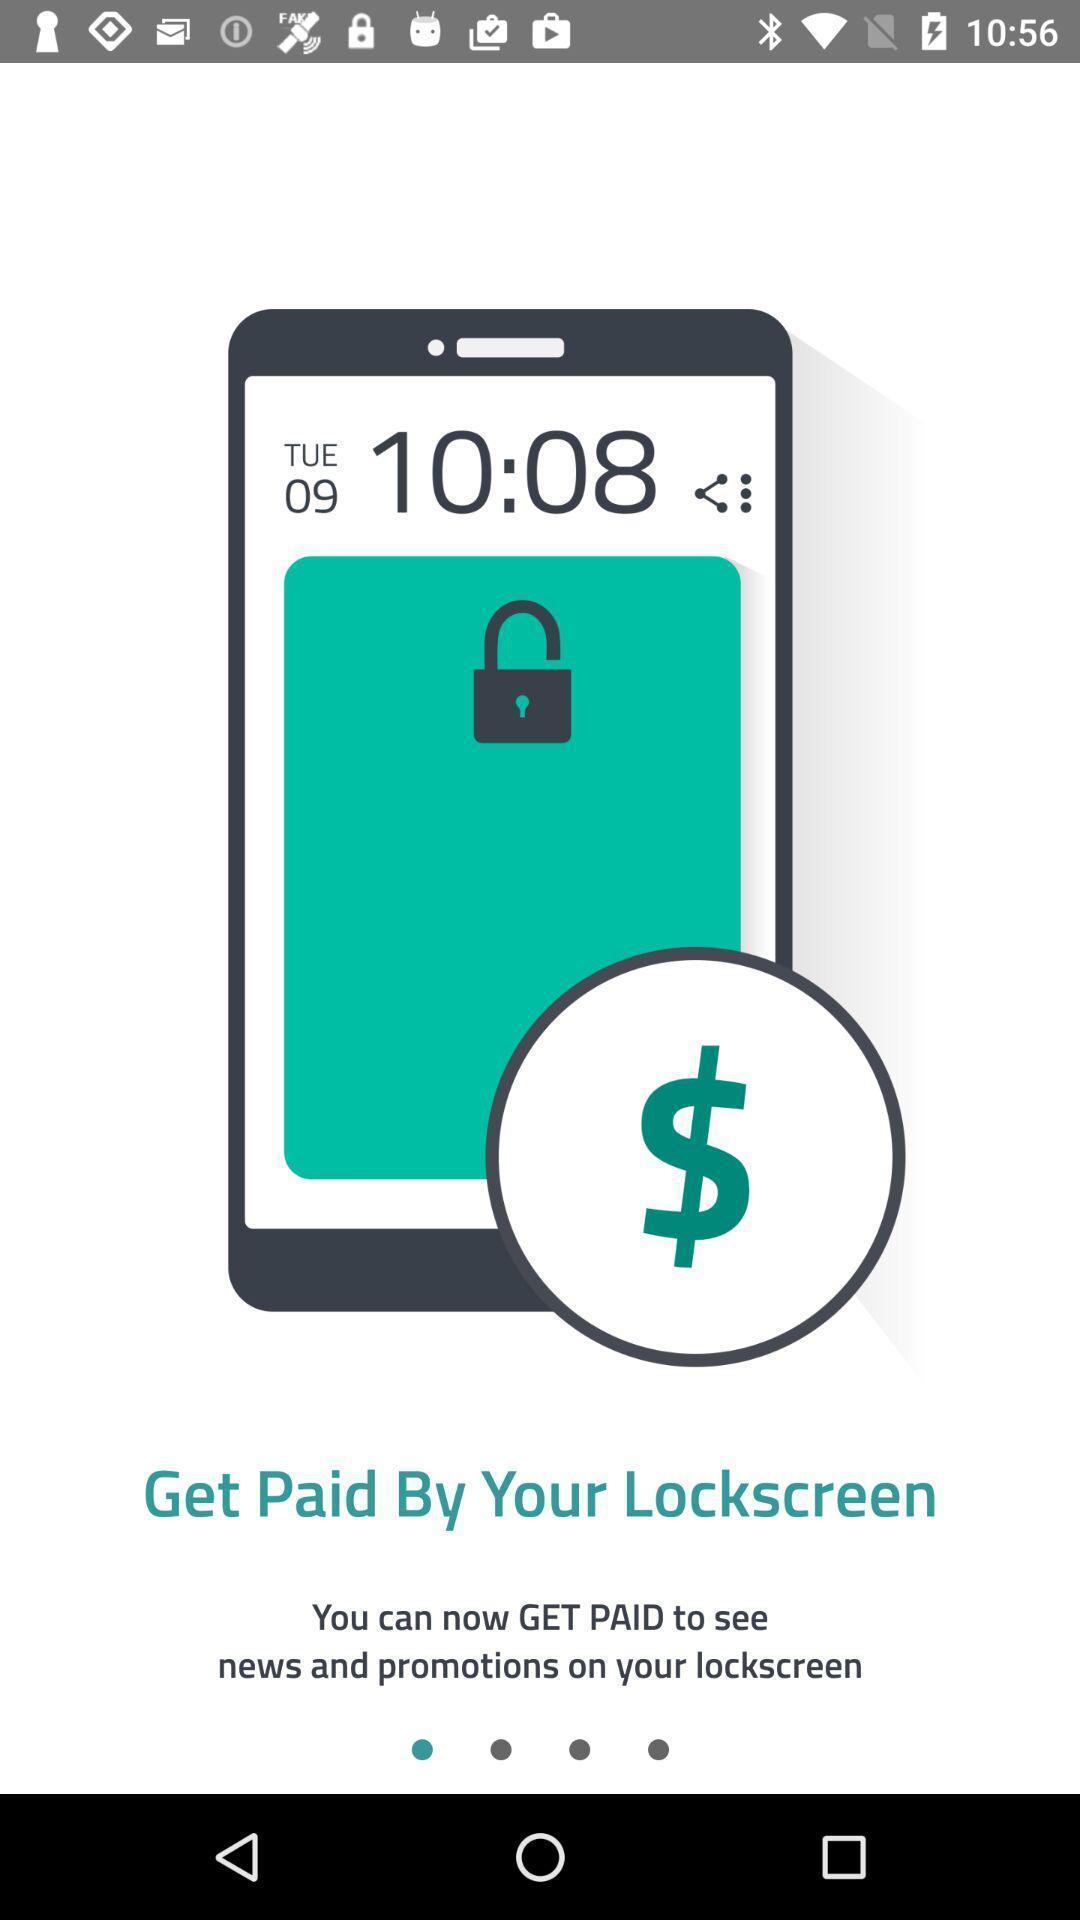Give me a narrative description of this picture. Welcome page. 